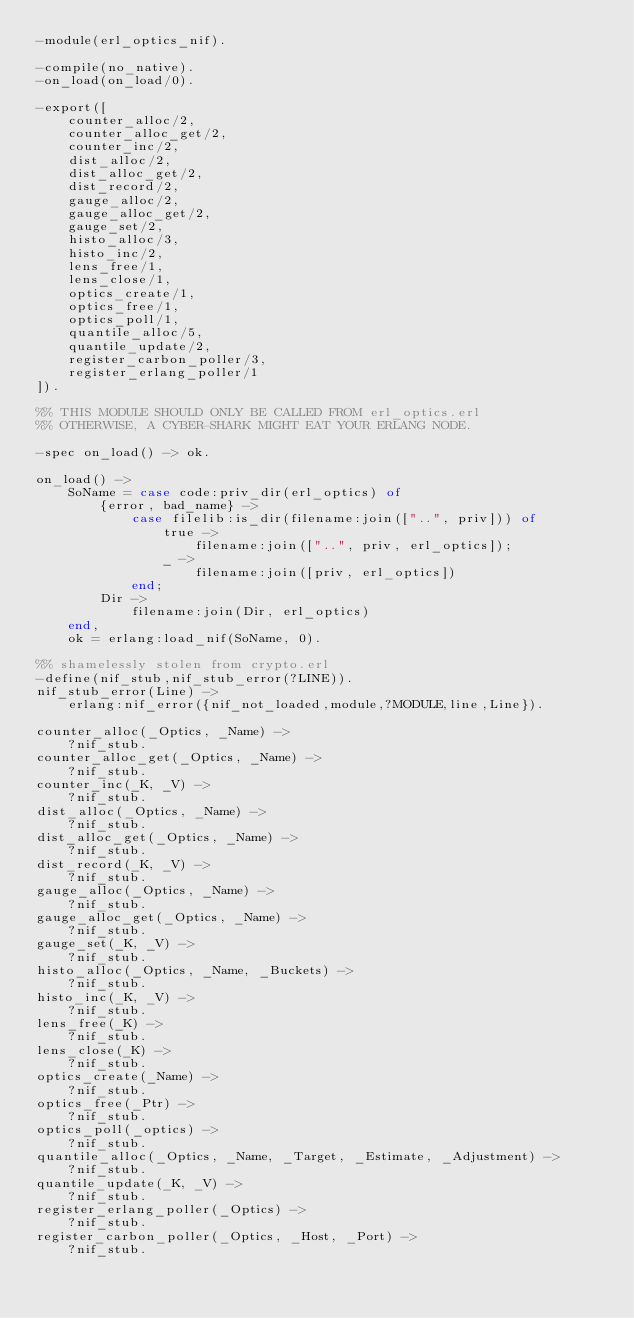<code> <loc_0><loc_0><loc_500><loc_500><_Erlang_>-module(erl_optics_nif).

-compile(no_native).
-on_load(on_load/0).

-export([
    counter_alloc/2,
    counter_alloc_get/2,
    counter_inc/2,
    dist_alloc/2,
    dist_alloc_get/2,
    dist_record/2,
    gauge_alloc/2,
    gauge_alloc_get/2,
    gauge_set/2,
    histo_alloc/3,
    histo_inc/2,
    lens_free/1,
    lens_close/1,
    optics_create/1,
    optics_free/1,
    optics_poll/1,
    quantile_alloc/5,
    quantile_update/2,
    register_carbon_poller/3,
    register_erlang_poller/1
]).

%% THIS MODULE SHOULD ONLY BE CALLED FROM erl_optics.erl
%% OTHERWISE, A CYBER-SHARK MIGHT EAT YOUR ERLANG NODE.

-spec on_load() -> ok.

on_load() ->
    SoName = case code:priv_dir(erl_optics) of
        {error, bad_name} ->
            case filelib:is_dir(filename:join(["..", priv])) of
                true ->
                    filename:join(["..", priv, erl_optics]);
                _ ->
                    filename:join([priv, erl_optics])
            end;
        Dir ->
            filename:join(Dir, erl_optics)
    end,
    ok = erlang:load_nif(SoName, 0).

%% shamelessly stolen from crypto.erl
-define(nif_stub,nif_stub_error(?LINE)).
nif_stub_error(Line) ->
    erlang:nif_error({nif_not_loaded,module,?MODULE,line,Line}).

counter_alloc(_Optics, _Name) ->
    ?nif_stub.
counter_alloc_get(_Optics, _Name) ->
    ?nif_stub.
counter_inc(_K, _V) ->
    ?nif_stub.
dist_alloc(_Optics, _Name) ->
    ?nif_stub.
dist_alloc_get(_Optics, _Name) ->
    ?nif_stub.
dist_record(_K, _V) ->
    ?nif_stub.
gauge_alloc(_Optics, _Name) ->
    ?nif_stub.
gauge_alloc_get(_Optics, _Name) ->
    ?nif_stub.
gauge_set(_K, _V) ->
    ?nif_stub.
histo_alloc(_Optics, _Name, _Buckets) ->
    ?nif_stub.
histo_inc(_K, _V) ->
    ?nif_stub.
lens_free(_K) ->
    ?nif_stub.
lens_close(_K) ->
    ?nif_stub.
optics_create(_Name) ->
    ?nif_stub.
optics_free(_Ptr) ->
    ?nif_stub.
optics_poll(_optics) ->
    ?nif_stub.
quantile_alloc(_Optics, _Name, _Target, _Estimate, _Adjustment) ->
    ?nif_stub.
quantile_update(_K, _V) ->
    ?nif_stub.
register_erlang_poller(_Optics) ->
    ?nif_stub.
register_carbon_poller(_Optics, _Host, _Port) ->
    ?nif_stub.
</code> 